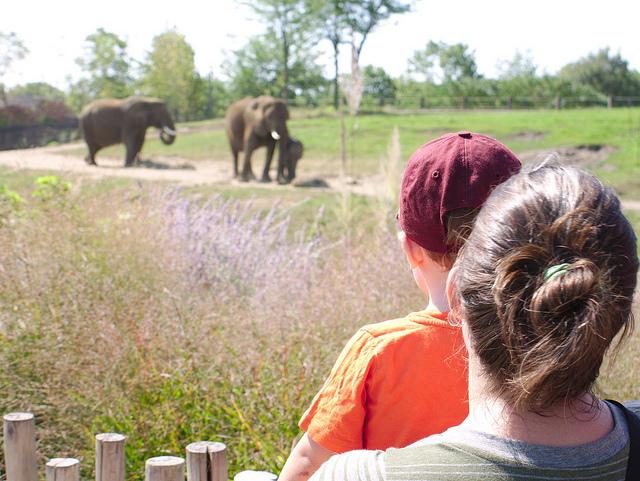Are the woman and child a reasonably safe distance from the animals?
Keep it brief. Yes. Is the boy wearing a hat?
Write a very short answer. Yes. What hairstyle is the woman's hair in?
Quick response, please. Bun. 